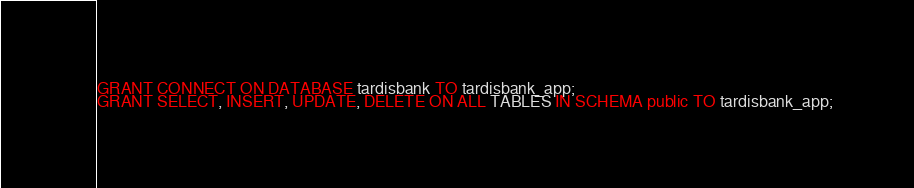<code> <loc_0><loc_0><loc_500><loc_500><_SQL_>GRANT CONNECT ON DATABASE tardisbank TO tardisbank_app;
GRANT SELECT, INSERT, UPDATE, DELETE ON ALL TABLES IN SCHEMA public TO tardisbank_app;</code> 